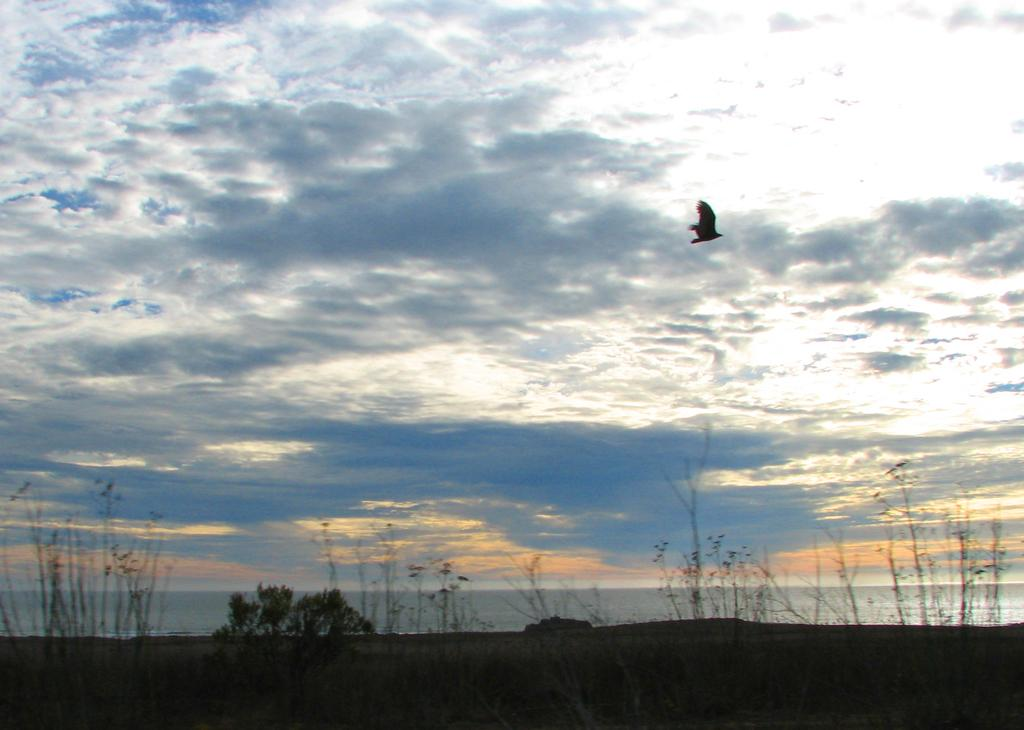What can be seen at the bottom of the image? The ground is visible at the bottom of the image. What is happening on the right side of the image? There is a bird flying on the right side of the image. What is the primary setting or backdrop of the image? The background of the image is the sky. What type of apparatus is being used by the bird to fly in the image? There is no apparatus present in the image; the bird is flying using its wings. Is the bird in the image sleeping or resting? No, the bird is flying, which indicates it is not sleeping or resting. 